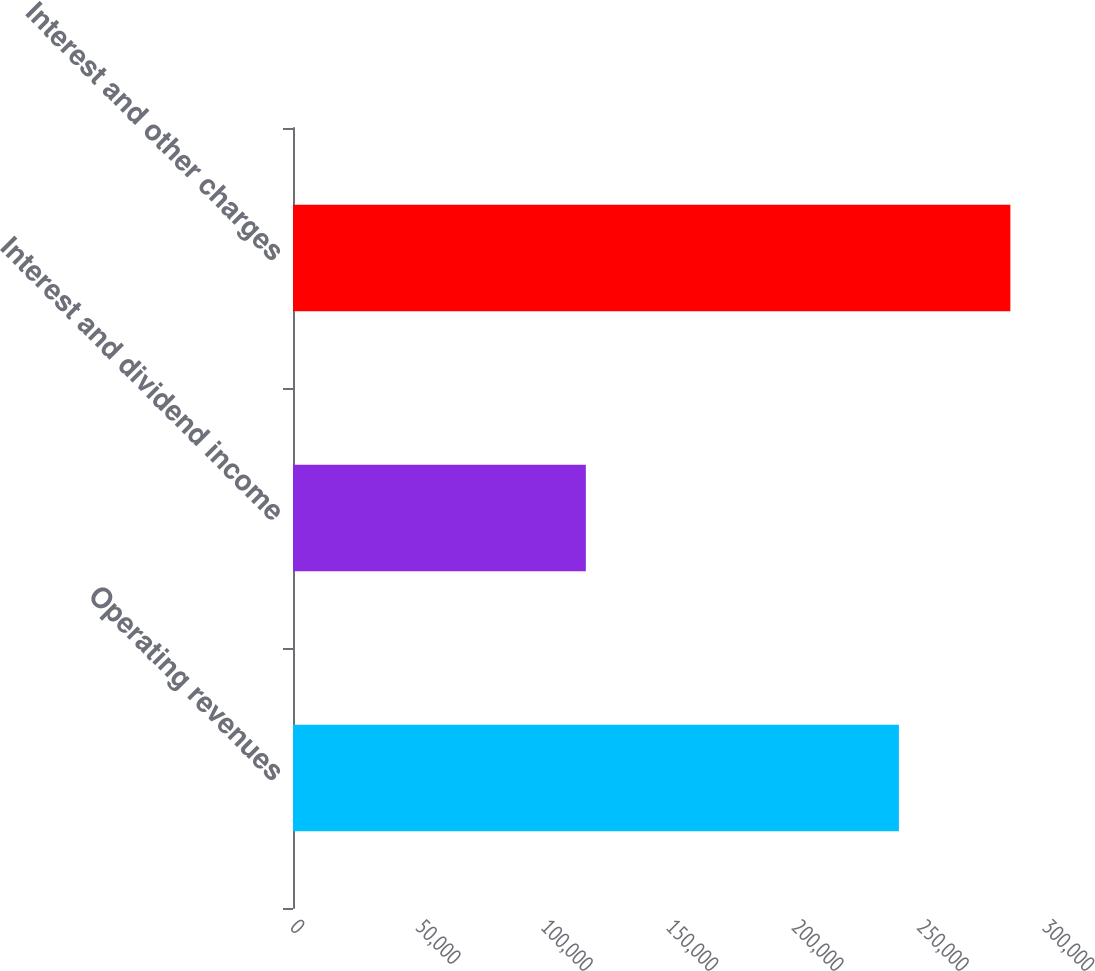Convert chart. <chart><loc_0><loc_0><loc_500><loc_500><bar_chart><fcel>Operating revenues<fcel>Interest and dividend income<fcel>Interest and other charges<nl><fcel>241715<fcel>116830<fcel>286185<nl></chart> 